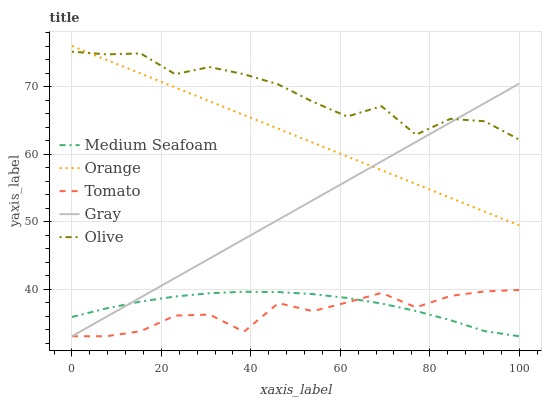Does Tomato have the minimum area under the curve?
Answer yes or no. Yes. Does Olive have the maximum area under the curve?
Answer yes or no. Yes. Does Olive have the minimum area under the curve?
Answer yes or no. No. Does Tomato have the maximum area under the curve?
Answer yes or no. No. Is Orange the smoothest?
Answer yes or no. Yes. Is Olive the roughest?
Answer yes or no. Yes. Is Tomato the smoothest?
Answer yes or no. No. Is Tomato the roughest?
Answer yes or no. No. Does Tomato have the lowest value?
Answer yes or no. Yes. Does Olive have the lowest value?
Answer yes or no. No. Does Orange have the highest value?
Answer yes or no. Yes. Does Tomato have the highest value?
Answer yes or no. No. Is Medium Seafoam less than Olive?
Answer yes or no. Yes. Is Orange greater than Tomato?
Answer yes or no. Yes. Does Orange intersect Olive?
Answer yes or no. Yes. Is Orange less than Olive?
Answer yes or no. No. Is Orange greater than Olive?
Answer yes or no. No. Does Medium Seafoam intersect Olive?
Answer yes or no. No. 